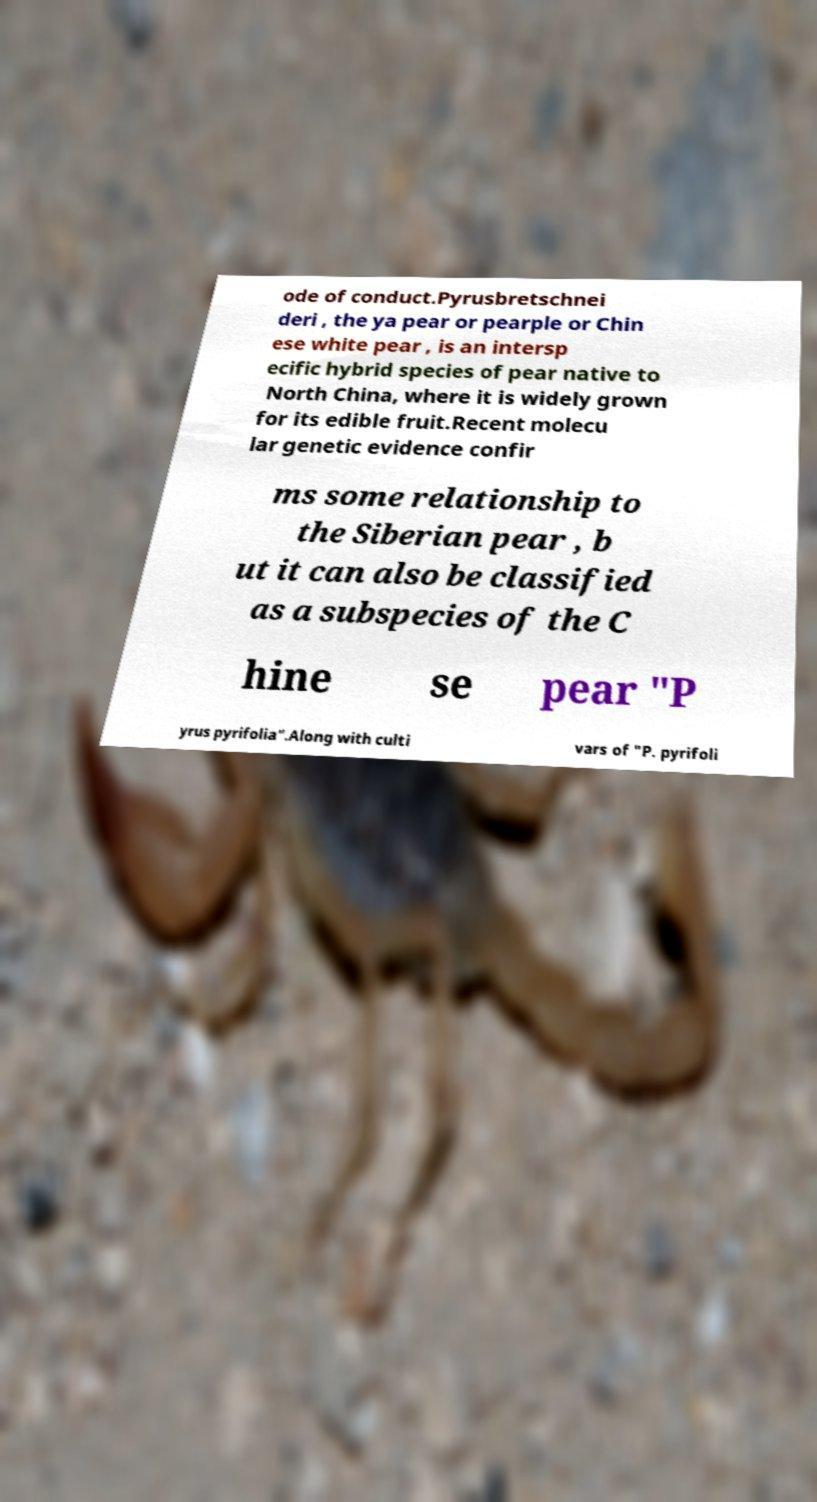Can you read and provide the text displayed in the image?This photo seems to have some interesting text. Can you extract and type it out for me? ode of conduct.Pyrusbretschnei deri , the ya pear or pearple or Chin ese white pear , is an intersp ecific hybrid species of pear native to North China, where it is widely grown for its edible fruit.Recent molecu lar genetic evidence confir ms some relationship to the Siberian pear , b ut it can also be classified as a subspecies of the C hine se pear "P yrus pyrifolia".Along with culti vars of "P. pyrifoli 